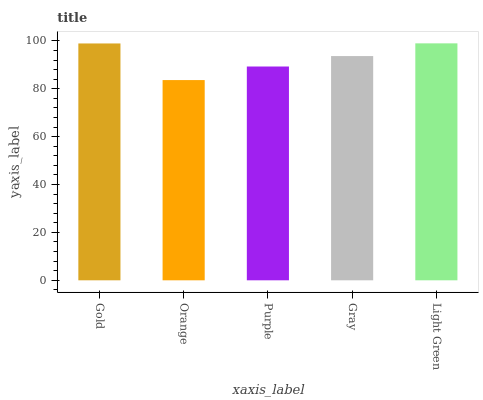Is Purple the minimum?
Answer yes or no. No. Is Purple the maximum?
Answer yes or no. No. Is Purple greater than Orange?
Answer yes or no. Yes. Is Orange less than Purple?
Answer yes or no. Yes. Is Orange greater than Purple?
Answer yes or no. No. Is Purple less than Orange?
Answer yes or no. No. Is Gray the high median?
Answer yes or no. Yes. Is Gray the low median?
Answer yes or no. Yes. Is Orange the high median?
Answer yes or no. No. Is Purple the low median?
Answer yes or no. No. 